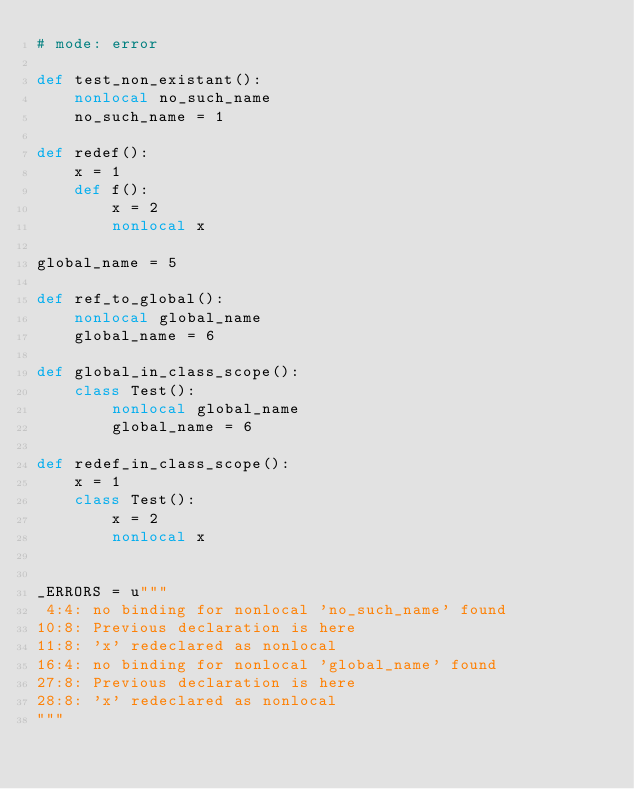<code> <loc_0><loc_0><loc_500><loc_500><_Cython_># mode: error

def test_non_existant():
    nonlocal no_such_name
    no_such_name = 1

def redef():
    x = 1
    def f():
        x = 2
        nonlocal x

global_name = 5

def ref_to_global():
    nonlocal global_name
    global_name = 6

def global_in_class_scope():
    class Test():
        nonlocal global_name
        global_name = 6

def redef_in_class_scope():
    x = 1
    class Test():
        x = 2
        nonlocal x


_ERRORS = u"""
 4:4: no binding for nonlocal 'no_such_name' found
10:8: Previous declaration is here
11:8: 'x' redeclared as nonlocal
16:4: no binding for nonlocal 'global_name' found
27:8: Previous declaration is here
28:8: 'x' redeclared as nonlocal
"""
</code> 